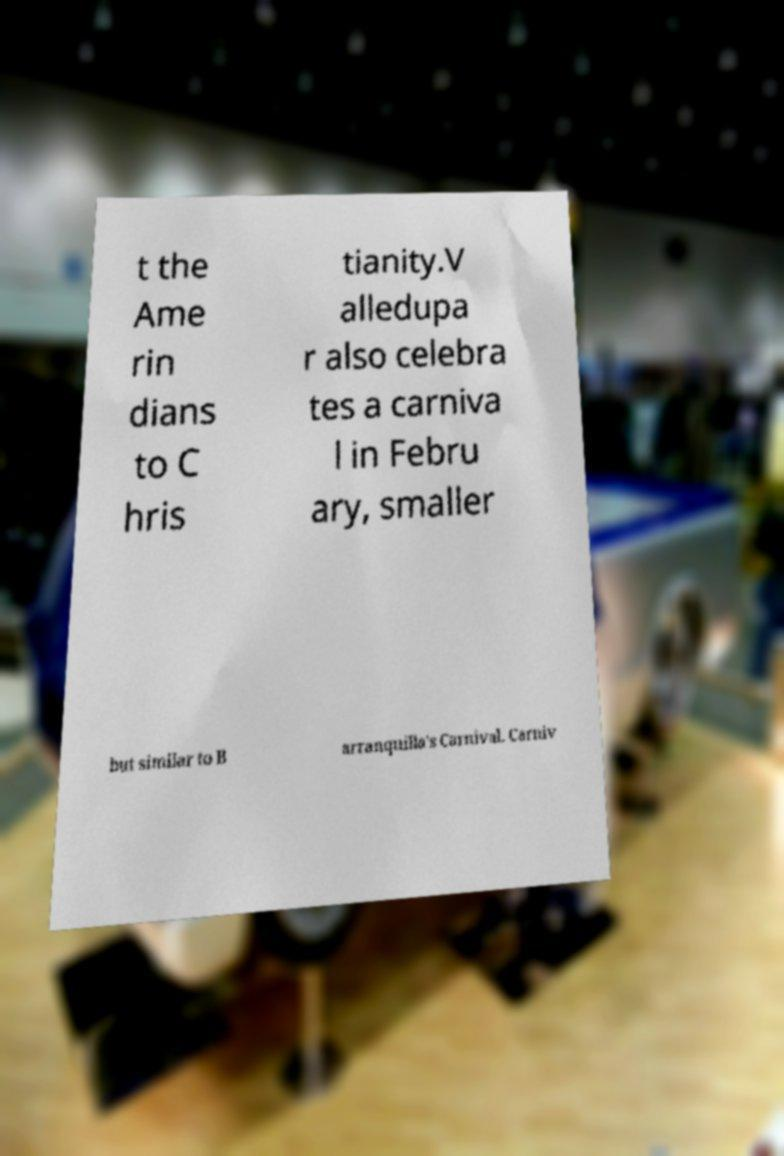Please identify and transcribe the text found in this image. t the Ame rin dians to C hris tianity.V alledupa r also celebra tes a carniva l in Febru ary, smaller but similar to B arranquilla's Carnival. Carniv 